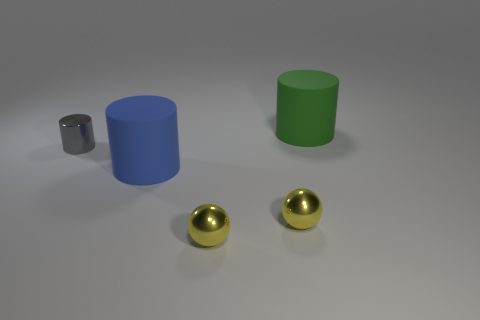Is the green cylinder the same size as the metal cylinder?
Offer a terse response. No. How many large things are behind the tiny gray metallic object and to the left of the green matte object?
Your response must be concise. 0. What number of gray things are cylinders or big things?
Provide a succinct answer. 1. How many metallic things are tiny blue cylinders or tiny gray things?
Your answer should be very brief. 1. Are any gray cylinders visible?
Offer a very short reply. Yes. Does the small gray object have the same shape as the large green matte object?
Provide a succinct answer. Yes. What number of cylinders are on the right side of the rubber cylinder on the left side of the cylinder that is right of the blue cylinder?
Offer a very short reply. 1. What is the object that is both to the right of the large blue thing and behind the big blue matte object made of?
Provide a short and direct response. Rubber. There is a thing that is both behind the large blue object and on the right side of the gray metal cylinder; what color is it?
Make the answer very short. Green. Is there anything else that is the same color as the small shiny cylinder?
Provide a short and direct response. No. 